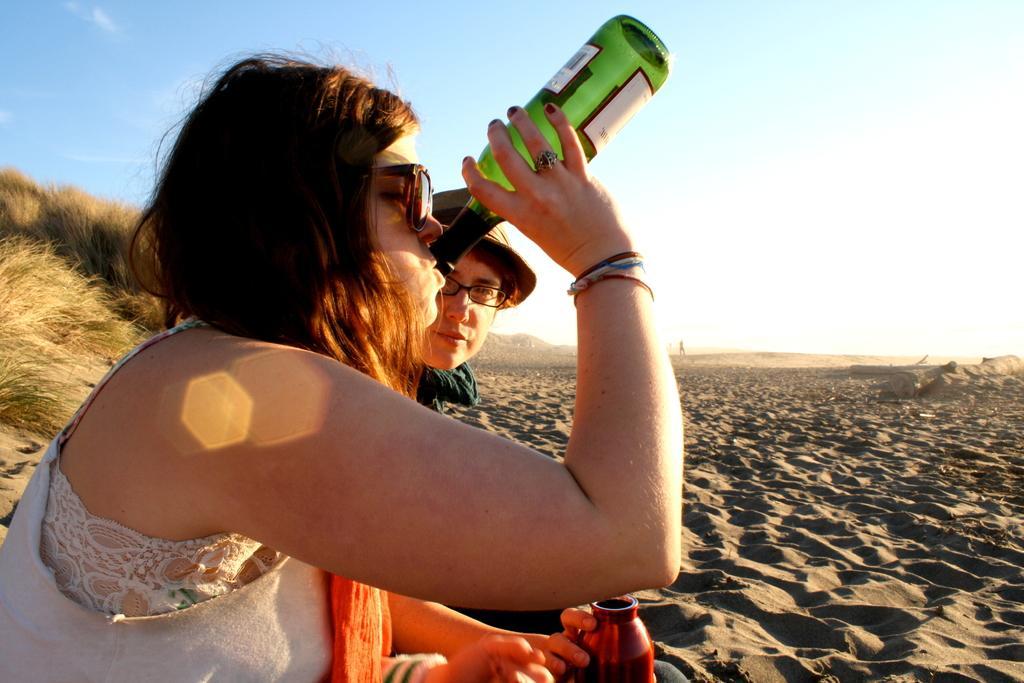Describe this image in one or two sentences. This is the picture of a lady who is holding the bottle and drinking and beside her there is a person who wore a spectacles sitting on the sand and behind them there is some grass. 